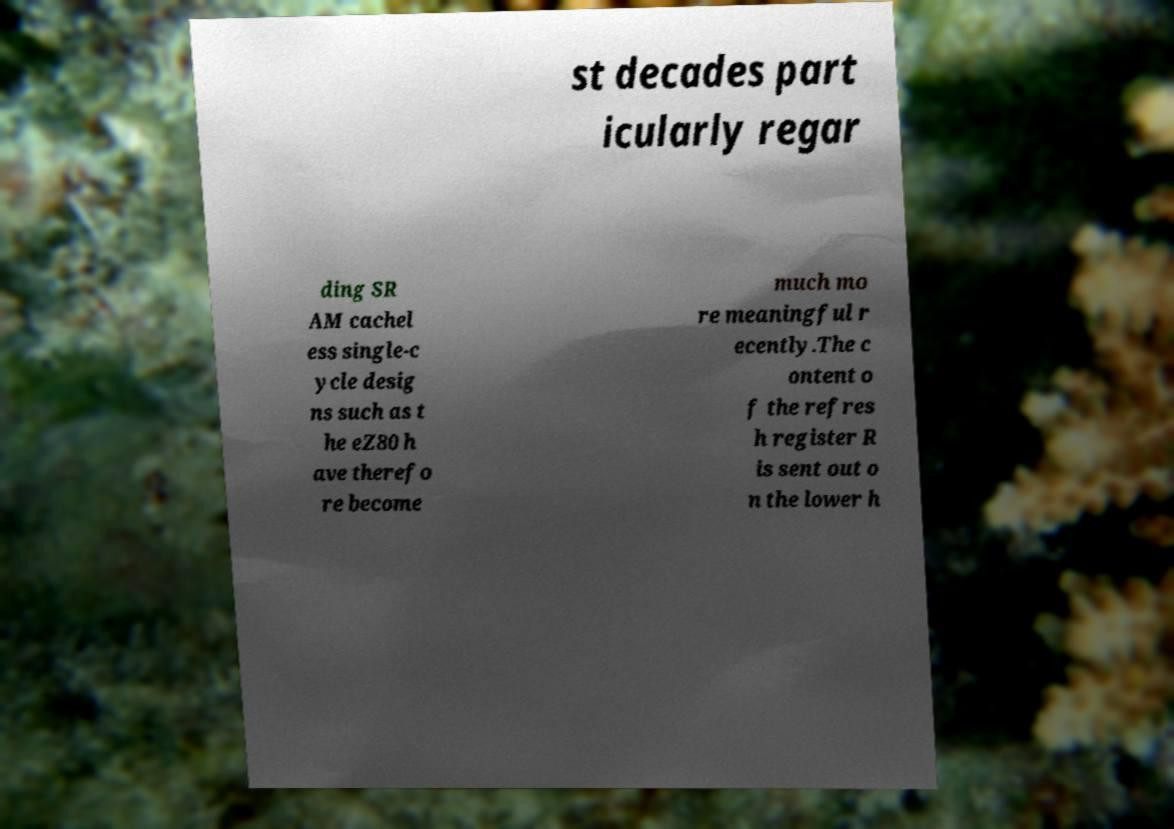Can you read and provide the text displayed in the image?This photo seems to have some interesting text. Can you extract and type it out for me? st decades part icularly regar ding SR AM cachel ess single-c ycle desig ns such as t he eZ80 h ave therefo re become much mo re meaningful r ecently.The c ontent o f the refres h register R is sent out o n the lower h 